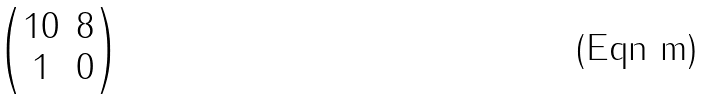<formula> <loc_0><loc_0><loc_500><loc_500>\begin{pmatrix} 1 0 & 8 \\ 1 & 0 \end{pmatrix}</formula> 